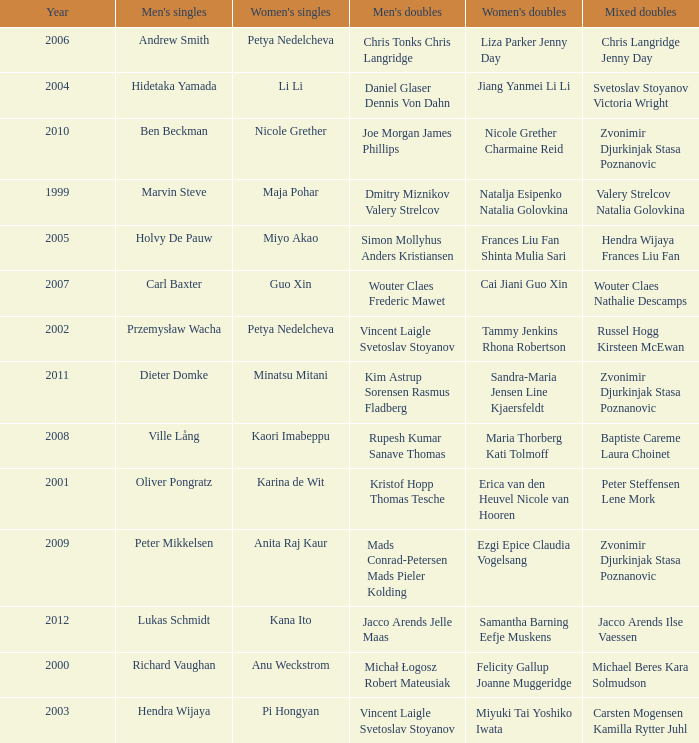Can you parse all the data within this table? {'header': ['Year', "Men's singles", "Women's singles", "Men's doubles", "Women's doubles", 'Mixed doubles'], 'rows': [['2006', 'Andrew Smith', 'Petya Nedelcheva', 'Chris Tonks Chris Langridge', 'Liza Parker Jenny Day', 'Chris Langridge Jenny Day'], ['2004', 'Hidetaka Yamada', 'Li Li', 'Daniel Glaser Dennis Von Dahn', 'Jiang Yanmei Li Li', 'Svetoslav Stoyanov Victoria Wright'], ['2010', 'Ben Beckman', 'Nicole Grether', 'Joe Morgan James Phillips', 'Nicole Grether Charmaine Reid', 'Zvonimir Djurkinjak Stasa Poznanovic'], ['1999', 'Marvin Steve', 'Maja Pohar', 'Dmitry Miznikov Valery Strelcov', 'Natalja Esipenko Natalia Golovkina', 'Valery Strelcov Natalia Golovkina'], ['2005', 'Holvy De Pauw', 'Miyo Akao', 'Simon Mollyhus Anders Kristiansen', 'Frances Liu Fan Shinta Mulia Sari', 'Hendra Wijaya Frances Liu Fan'], ['2007', 'Carl Baxter', 'Guo Xin', 'Wouter Claes Frederic Mawet', 'Cai Jiani Guo Xin', 'Wouter Claes Nathalie Descamps'], ['2002', 'Przemysław Wacha', 'Petya Nedelcheva', 'Vincent Laigle Svetoslav Stoyanov', 'Tammy Jenkins Rhona Robertson', 'Russel Hogg Kirsteen McEwan'], ['2011', 'Dieter Domke', 'Minatsu Mitani', 'Kim Astrup Sorensen Rasmus Fladberg', 'Sandra-Maria Jensen Line Kjaersfeldt', 'Zvonimir Djurkinjak Stasa Poznanovic'], ['2008', 'Ville Lång', 'Kaori Imabeppu', 'Rupesh Kumar Sanave Thomas', 'Maria Thorberg Kati Tolmoff', 'Baptiste Careme Laura Choinet'], ['2001', 'Oliver Pongratz', 'Karina de Wit', 'Kristof Hopp Thomas Tesche', 'Erica van den Heuvel Nicole van Hooren', 'Peter Steffensen Lene Mork'], ['2009', 'Peter Mikkelsen', 'Anita Raj Kaur', 'Mads Conrad-Petersen Mads Pieler Kolding', 'Ezgi Epice Claudia Vogelsang', 'Zvonimir Djurkinjak Stasa Poznanovic'], ['2012', 'Lukas Schmidt', 'Kana Ito', 'Jacco Arends Jelle Maas', 'Samantha Barning Eefje Muskens', 'Jacco Arends Ilse Vaessen'], ['2000', 'Richard Vaughan', 'Anu Weckstrom', 'Michał Łogosz Robert Mateusiak', 'Felicity Gallup Joanne Muggeridge', 'Michael Beres Kara Solmudson'], ['2003', 'Hendra Wijaya', 'Pi Hongyan', 'Vincent Laigle Svetoslav Stoyanov', 'Miyuki Tai Yoshiko Iwata', 'Carsten Mogensen Kamilla Rytter Juhl']]} What's the first year that Guo Xin featured in women's singles? 2007.0. 